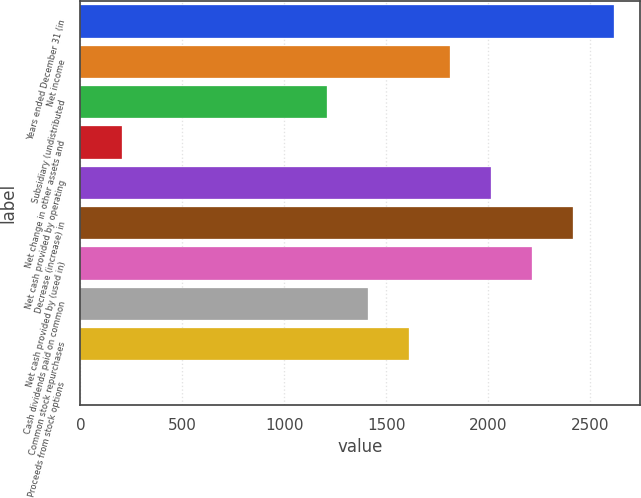Convert chart. <chart><loc_0><loc_0><loc_500><loc_500><bar_chart><fcel>Years ended December 31 (in<fcel>Net income<fcel>Subsidiary (undistributed<fcel>Net change in other assets and<fcel>Net cash provided by operating<fcel>Decrease (increase) in<fcel>Net cash provided by (used in)<fcel>Cash dividends paid on common<fcel>Common stock repurchases<fcel>Proceeds from stock options<nl><fcel>2615.51<fcel>1810.83<fcel>1207.32<fcel>201.47<fcel>2012<fcel>2414.34<fcel>2213.17<fcel>1408.49<fcel>1609.66<fcel>0.3<nl></chart> 